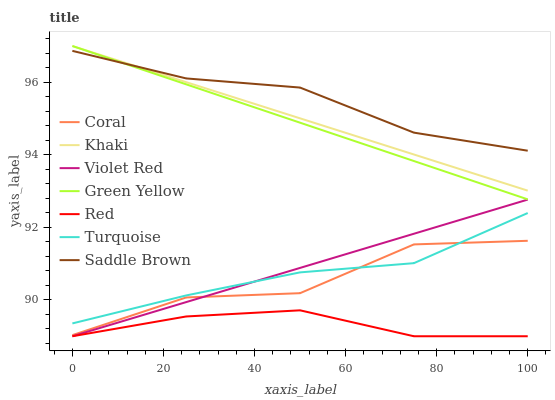Does Red have the minimum area under the curve?
Answer yes or no. Yes. Does Saddle Brown have the maximum area under the curve?
Answer yes or no. Yes. Does Khaki have the minimum area under the curve?
Answer yes or no. No. Does Khaki have the maximum area under the curve?
Answer yes or no. No. Is Violet Red the smoothest?
Answer yes or no. Yes. Is Coral the roughest?
Answer yes or no. Yes. Is Khaki the smoothest?
Answer yes or no. No. Is Khaki the roughest?
Answer yes or no. No. Does Violet Red have the lowest value?
Answer yes or no. Yes. Does Khaki have the lowest value?
Answer yes or no. No. Does Green Yellow have the highest value?
Answer yes or no. Yes. Does Coral have the highest value?
Answer yes or no. No. Is Red less than Turquoise?
Answer yes or no. Yes. Is Khaki greater than Violet Red?
Answer yes or no. Yes. Does Turquoise intersect Coral?
Answer yes or no. Yes. Is Turquoise less than Coral?
Answer yes or no. No. Is Turquoise greater than Coral?
Answer yes or no. No. Does Red intersect Turquoise?
Answer yes or no. No. 